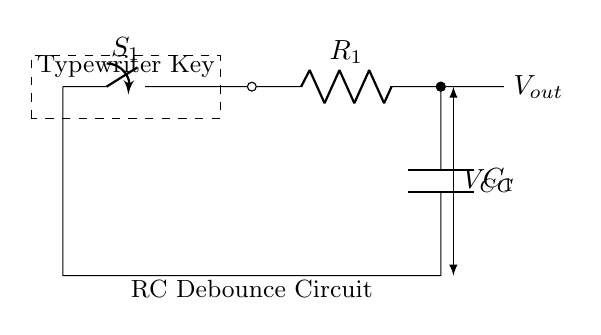What is the component labeled R? The component labeled R is a resistor, which is used to limit current flow in a circuit. In the diagram, it is shown with the label R_1, indicating that it is the first resistor in this circuit.
Answer: Resistor What does the component labeled C represent? The component labeled C represents a capacitor, which stores electrical energy temporarily. In the diagram, it is referred to as C_1, indicating it is the first capacitor in the circuit.
Answer: Capacitor What is the function of the switch S_1 in this circuit? The switch S_1 controls the connection in the circuit. When it is closed, it allows current to flow through the resistor and capacitor, enabling the debounce function. When open, it interrupts the circuit.
Answer: Control What is the purpose of the RC debounce circuit? The purpose of the RC debounce circuit is to eliminate multiple signals from a mechanical switch, ensuring that only one signal is sent when the key switch is pressed. This is especially important in devices like typewriters to prevent erroneous inputs.
Answer: Eliminate bounce How does the time constant affect the debounce time? The time constant, τ (tau), is calculated as the product of resistance (R) and capacitance (C) in the circuit. It determines how quickly the voltage across the capacitor will charge or discharge, thereby affecting how long it takes for the circuit to stabilize after a keypress. A larger time constant results in longer debounce time.
Answer: R times C What is the voltage output when the switch is closed? When the switch is closed, the output voltage at V_out can be considered approximately equal to the supply voltage V_CC after the capacitor is fully charged. However, immediately after the switch closure, the voltage will rise from 0 volts to V_CC.
Answer: V_CC 